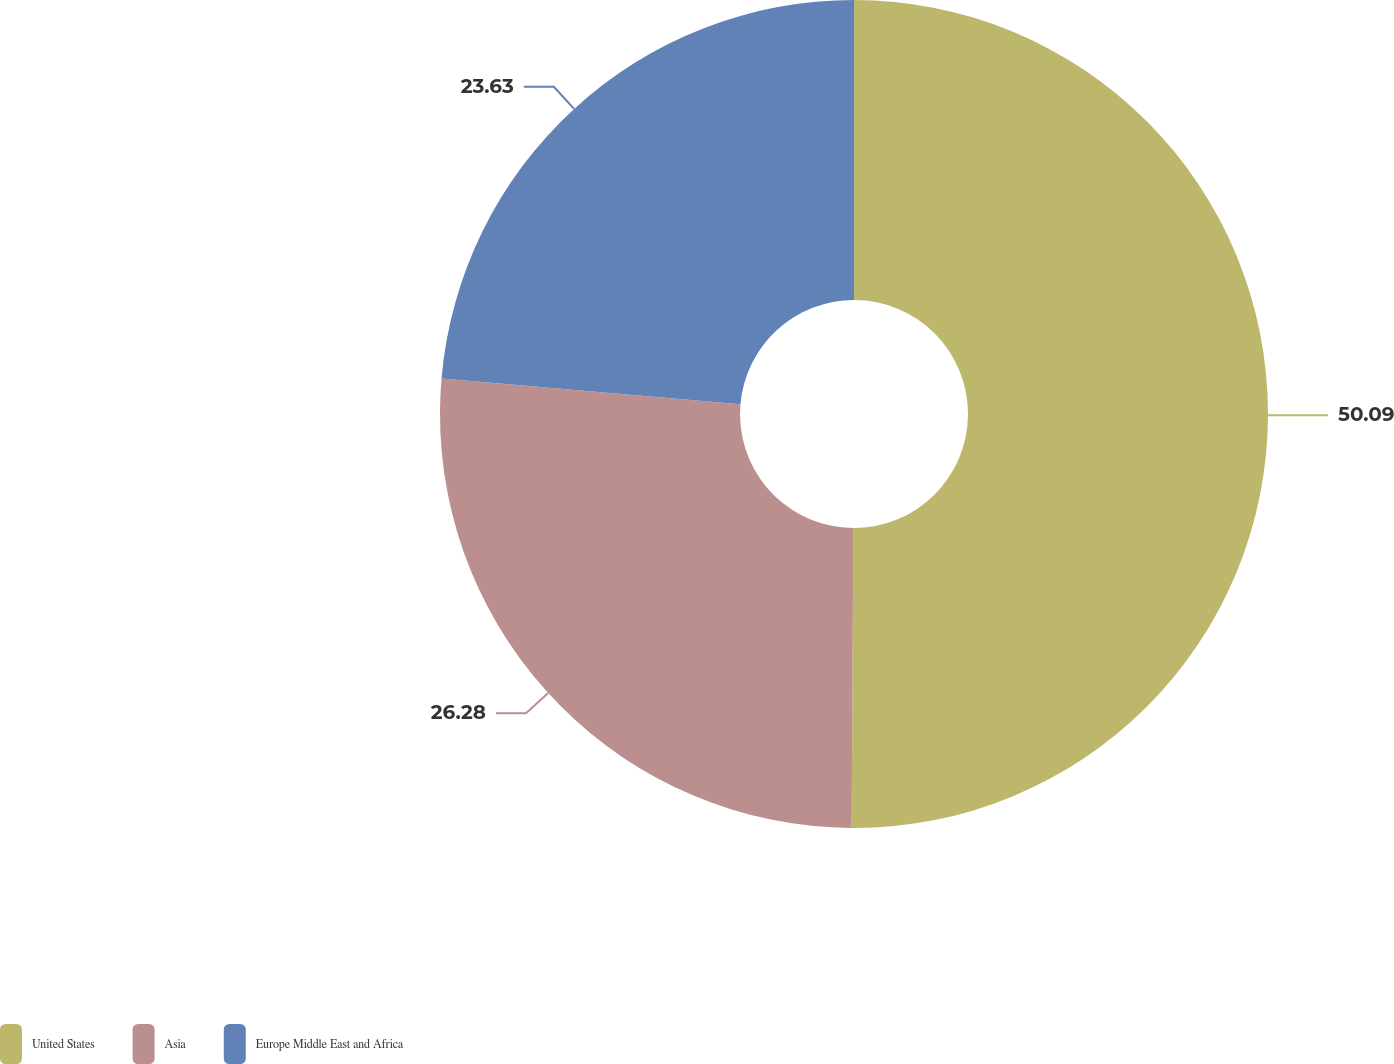Convert chart. <chart><loc_0><loc_0><loc_500><loc_500><pie_chart><fcel>United States<fcel>Asia<fcel>Europe Middle East and Africa<nl><fcel>50.09%<fcel>26.28%<fcel>23.63%<nl></chart> 